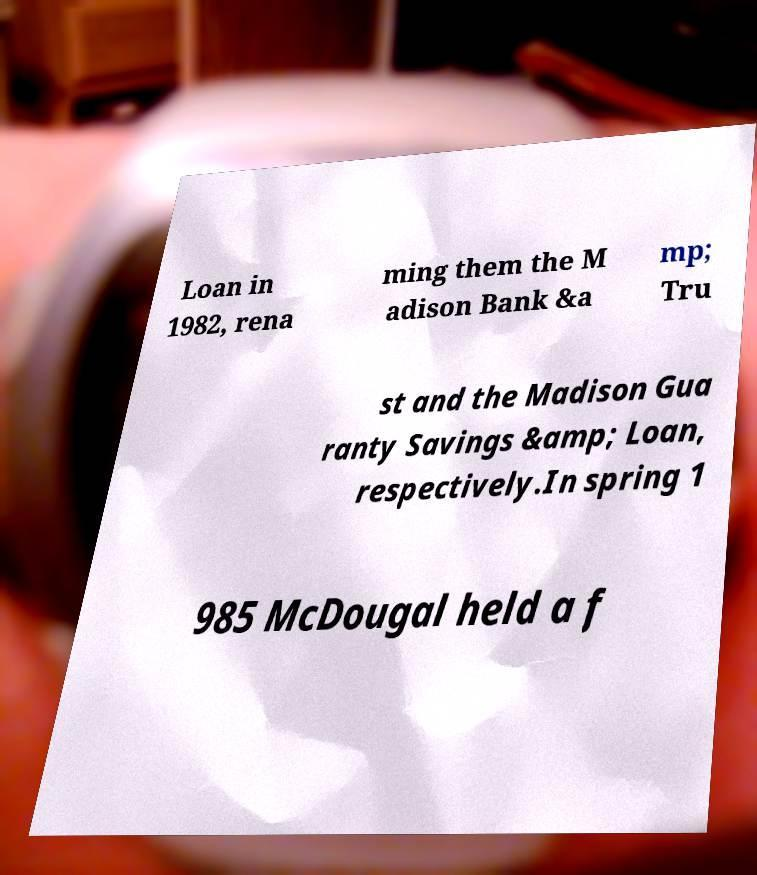Can you accurately transcribe the text from the provided image for me? Loan in 1982, rena ming them the M adison Bank &a mp; Tru st and the Madison Gua ranty Savings &amp; Loan, respectively.In spring 1 985 McDougal held a f 